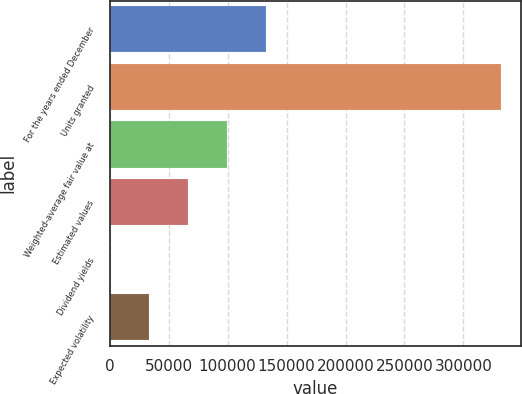Convert chart. <chart><loc_0><loc_0><loc_500><loc_500><bar_chart><fcel>For the years ended December<fcel>Units granted<fcel>Weighted-average fair value at<fcel>Estimated values<fcel>Dividend yields<fcel>Expected volatility<nl><fcel>132716<fcel>331788<fcel>99537.7<fcel>66359<fcel>1.8<fcel>33180.4<nl></chart> 